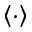<formula> <loc_0><loc_0><loc_500><loc_500>\left \langle \cdot \right \rangle</formula> 